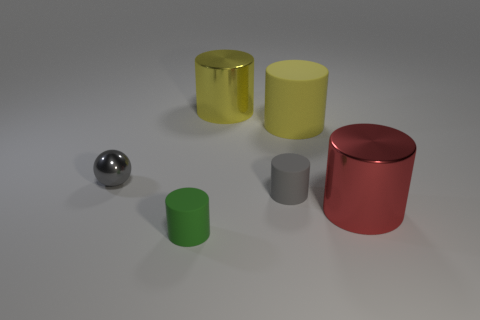Subtract all green cylinders. How many cylinders are left? 4 Subtract all red cylinders. How many cylinders are left? 4 Subtract all blue cylinders. Subtract all green cubes. How many cylinders are left? 5 Add 2 green things. How many objects exist? 8 Subtract all balls. How many objects are left? 5 Subtract all gray metal objects. Subtract all spheres. How many objects are left? 4 Add 4 matte objects. How many matte objects are left? 7 Add 5 big matte things. How many big matte things exist? 6 Subtract 0 gray cubes. How many objects are left? 6 